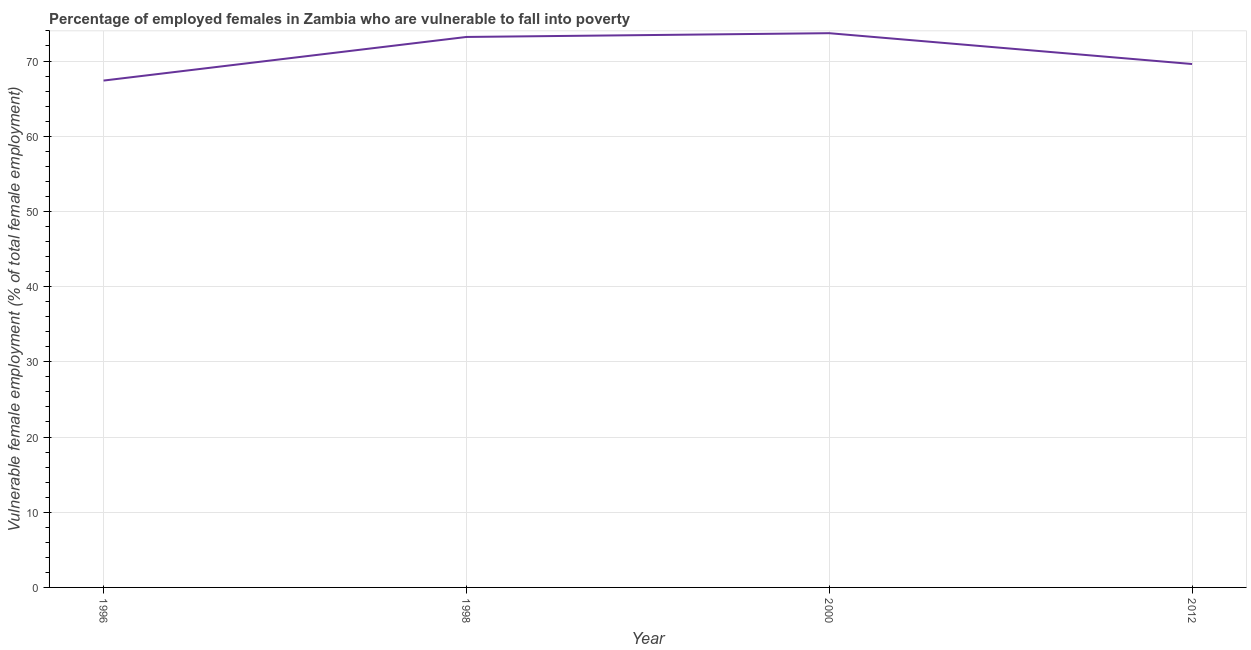What is the percentage of employed females who are vulnerable to fall into poverty in 1996?
Provide a short and direct response. 67.4. Across all years, what is the maximum percentage of employed females who are vulnerable to fall into poverty?
Make the answer very short. 73.7. Across all years, what is the minimum percentage of employed females who are vulnerable to fall into poverty?
Your answer should be very brief. 67.4. In which year was the percentage of employed females who are vulnerable to fall into poverty maximum?
Make the answer very short. 2000. In which year was the percentage of employed females who are vulnerable to fall into poverty minimum?
Ensure brevity in your answer.  1996. What is the sum of the percentage of employed females who are vulnerable to fall into poverty?
Offer a terse response. 283.9. What is the difference between the percentage of employed females who are vulnerable to fall into poverty in 1996 and 1998?
Your answer should be compact. -5.8. What is the average percentage of employed females who are vulnerable to fall into poverty per year?
Keep it short and to the point. 70.97. What is the median percentage of employed females who are vulnerable to fall into poverty?
Provide a succinct answer. 71.4. In how many years, is the percentage of employed females who are vulnerable to fall into poverty greater than 30 %?
Give a very brief answer. 4. What is the ratio of the percentage of employed females who are vulnerable to fall into poverty in 1998 to that in 2012?
Ensure brevity in your answer.  1.05. Is the difference between the percentage of employed females who are vulnerable to fall into poverty in 2000 and 2012 greater than the difference between any two years?
Your answer should be compact. No. What is the difference between the highest and the second highest percentage of employed females who are vulnerable to fall into poverty?
Provide a short and direct response. 0.5. Is the sum of the percentage of employed females who are vulnerable to fall into poverty in 1996 and 2012 greater than the maximum percentage of employed females who are vulnerable to fall into poverty across all years?
Your response must be concise. Yes. What is the difference between the highest and the lowest percentage of employed females who are vulnerable to fall into poverty?
Provide a short and direct response. 6.3. In how many years, is the percentage of employed females who are vulnerable to fall into poverty greater than the average percentage of employed females who are vulnerable to fall into poverty taken over all years?
Keep it short and to the point. 2. How many lines are there?
Offer a terse response. 1. Are the values on the major ticks of Y-axis written in scientific E-notation?
Offer a terse response. No. Does the graph contain any zero values?
Your response must be concise. No. Does the graph contain grids?
Offer a terse response. Yes. What is the title of the graph?
Keep it short and to the point. Percentage of employed females in Zambia who are vulnerable to fall into poverty. What is the label or title of the X-axis?
Offer a very short reply. Year. What is the label or title of the Y-axis?
Keep it short and to the point. Vulnerable female employment (% of total female employment). What is the Vulnerable female employment (% of total female employment) of 1996?
Make the answer very short. 67.4. What is the Vulnerable female employment (% of total female employment) in 1998?
Your answer should be very brief. 73.2. What is the Vulnerable female employment (% of total female employment) in 2000?
Offer a terse response. 73.7. What is the Vulnerable female employment (% of total female employment) in 2012?
Offer a terse response. 69.6. What is the difference between the Vulnerable female employment (% of total female employment) in 1996 and 1998?
Offer a terse response. -5.8. What is the difference between the Vulnerable female employment (% of total female employment) in 1996 and 2000?
Give a very brief answer. -6.3. What is the difference between the Vulnerable female employment (% of total female employment) in 1996 and 2012?
Offer a very short reply. -2.2. What is the ratio of the Vulnerable female employment (% of total female employment) in 1996 to that in 1998?
Keep it short and to the point. 0.92. What is the ratio of the Vulnerable female employment (% of total female employment) in 1996 to that in 2000?
Keep it short and to the point. 0.92. What is the ratio of the Vulnerable female employment (% of total female employment) in 1998 to that in 2000?
Offer a very short reply. 0.99. What is the ratio of the Vulnerable female employment (% of total female employment) in 1998 to that in 2012?
Your answer should be very brief. 1.05. What is the ratio of the Vulnerable female employment (% of total female employment) in 2000 to that in 2012?
Keep it short and to the point. 1.06. 